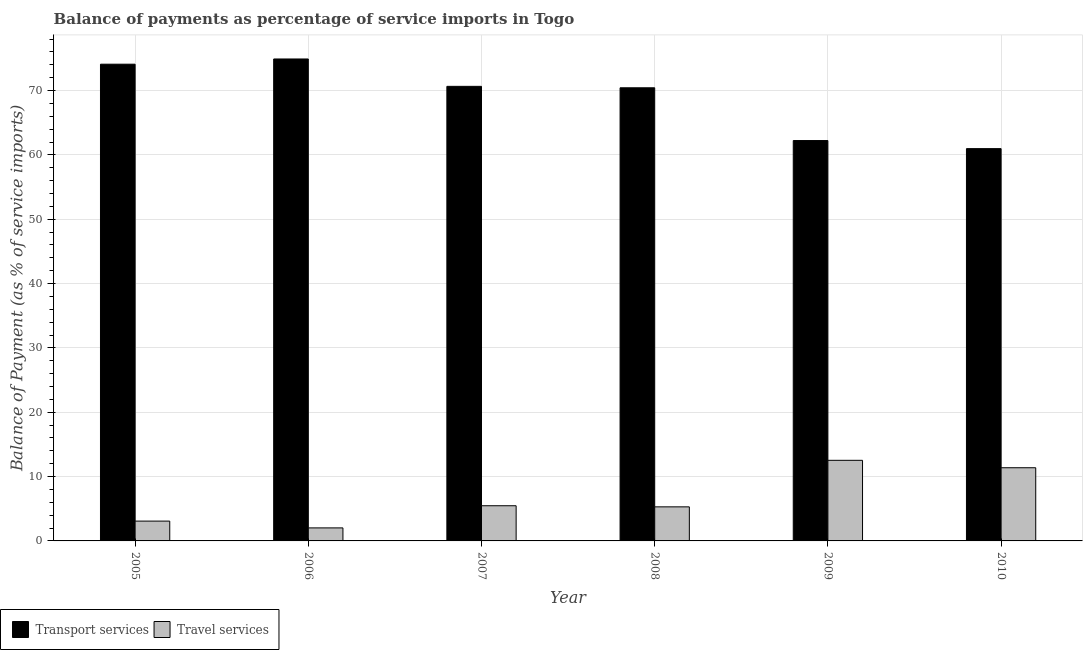Are the number of bars per tick equal to the number of legend labels?
Ensure brevity in your answer.  Yes. How many bars are there on the 5th tick from the left?
Ensure brevity in your answer.  2. What is the balance of payments of transport services in 2006?
Offer a very short reply. 74.91. Across all years, what is the maximum balance of payments of transport services?
Offer a terse response. 74.91. Across all years, what is the minimum balance of payments of travel services?
Give a very brief answer. 2.03. In which year was the balance of payments of transport services maximum?
Your response must be concise. 2006. What is the total balance of payments of travel services in the graph?
Provide a short and direct response. 39.77. What is the difference between the balance of payments of transport services in 2007 and that in 2008?
Keep it short and to the point. 0.22. What is the difference between the balance of payments of travel services in 2006 and the balance of payments of transport services in 2007?
Your response must be concise. -3.44. What is the average balance of payments of transport services per year?
Give a very brief answer. 68.88. What is the ratio of the balance of payments of transport services in 2007 to that in 2008?
Your answer should be compact. 1. What is the difference between the highest and the second highest balance of payments of travel services?
Offer a very short reply. 1.15. What is the difference between the highest and the lowest balance of payments of transport services?
Your response must be concise. 13.94. In how many years, is the balance of payments of travel services greater than the average balance of payments of travel services taken over all years?
Provide a succinct answer. 2. Is the sum of the balance of payments of travel services in 2008 and 2009 greater than the maximum balance of payments of transport services across all years?
Offer a terse response. Yes. What does the 1st bar from the left in 2008 represents?
Your response must be concise. Transport services. What does the 2nd bar from the right in 2008 represents?
Make the answer very short. Transport services. What is the difference between two consecutive major ticks on the Y-axis?
Your answer should be very brief. 10. Does the graph contain any zero values?
Ensure brevity in your answer.  No. Does the graph contain grids?
Your response must be concise. Yes. How many legend labels are there?
Offer a terse response. 2. What is the title of the graph?
Your answer should be compact. Balance of payments as percentage of service imports in Togo. What is the label or title of the Y-axis?
Provide a succinct answer. Balance of Payment (as % of service imports). What is the Balance of Payment (as % of service imports) in Transport services in 2005?
Make the answer very short. 74.1. What is the Balance of Payment (as % of service imports) of Travel services in 2005?
Your response must be concise. 3.08. What is the Balance of Payment (as % of service imports) of Transport services in 2006?
Keep it short and to the point. 74.91. What is the Balance of Payment (as % of service imports) in Travel services in 2006?
Provide a succinct answer. 2.03. What is the Balance of Payment (as % of service imports) in Transport services in 2007?
Provide a short and direct response. 70.65. What is the Balance of Payment (as % of service imports) of Travel services in 2007?
Your response must be concise. 5.47. What is the Balance of Payment (as % of service imports) in Transport services in 2008?
Provide a succinct answer. 70.43. What is the Balance of Payment (as % of service imports) in Travel services in 2008?
Your answer should be compact. 5.3. What is the Balance of Payment (as % of service imports) in Transport services in 2009?
Make the answer very short. 62.23. What is the Balance of Payment (as % of service imports) of Travel services in 2009?
Make the answer very short. 12.53. What is the Balance of Payment (as % of service imports) of Transport services in 2010?
Make the answer very short. 60.97. What is the Balance of Payment (as % of service imports) in Travel services in 2010?
Keep it short and to the point. 11.37. Across all years, what is the maximum Balance of Payment (as % of service imports) in Transport services?
Ensure brevity in your answer.  74.91. Across all years, what is the maximum Balance of Payment (as % of service imports) in Travel services?
Provide a succinct answer. 12.53. Across all years, what is the minimum Balance of Payment (as % of service imports) of Transport services?
Provide a succinct answer. 60.97. Across all years, what is the minimum Balance of Payment (as % of service imports) of Travel services?
Your response must be concise. 2.03. What is the total Balance of Payment (as % of service imports) in Transport services in the graph?
Make the answer very short. 413.3. What is the total Balance of Payment (as % of service imports) in Travel services in the graph?
Your answer should be compact. 39.77. What is the difference between the Balance of Payment (as % of service imports) of Transport services in 2005 and that in 2006?
Your response must be concise. -0.81. What is the difference between the Balance of Payment (as % of service imports) of Travel services in 2005 and that in 2006?
Provide a short and direct response. 1.06. What is the difference between the Balance of Payment (as % of service imports) in Transport services in 2005 and that in 2007?
Offer a terse response. 3.45. What is the difference between the Balance of Payment (as % of service imports) in Travel services in 2005 and that in 2007?
Offer a terse response. -2.39. What is the difference between the Balance of Payment (as % of service imports) in Transport services in 2005 and that in 2008?
Your response must be concise. 3.67. What is the difference between the Balance of Payment (as % of service imports) of Travel services in 2005 and that in 2008?
Provide a succinct answer. -2.22. What is the difference between the Balance of Payment (as % of service imports) of Transport services in 2005 and that in 2009?
Offer a terse response. 11.87. What is the difference between the Balance of Payment (as % of service imports) of Travel services in 2005 and that in 2009?
Make the answer very short. -9.45. What is the difference between the Balance of Payment (as % of service imports) in Transport services in 2005 and that in 2010?
Your response must be concise. 13.13. What is the difference between the Balance of Payment (as % of service imports) in Travel services in 2005 and that in 2010?
Give a very brief answer. -8.29. What is the difference between the Balance of Payment (as % of service imports) of Transport services in 2006 and that in 2007?
Ensure brevity in your answer.  4.26. What is the difference between the Balance of Payment (as % of service imports) of Travel services in 2006 and that in 2007?
Your answer should be compact. -3.44. What is the difference between the Balance of Payment (as % of service imports) in Transport services in 2006 and that in 2008?
Keep it short and to the point. 4.48. What is the difference between the Balance of Payment (as % of service imports) in Travel services in 2006 and that in 2008?
Offer a terse response. -3.27. What is the difference between the Balance of Payment (as % of service imports) of Transport services in 2006 and that in 2009?
Keep it short and to the point. 12.68. What is the difference between the Balance of Payment (as % of service imports) of Travel services in 2006 and that in 2009?
Your response must be concise. -10.5. What is the difference between the Balance of Payment (as % of service imports) in Transport services in 2006 and that in 2010?
Provide a succinct answer. 13.94. What is the difference between the Balance of Payment (as % of service imports) of Travel services in 2006 and that in 2010?
Give a very brief answer. -9.35. What is the difference between the Balance of Payment (as % of service imports) of Transport services in 2007 and that in 2008?
Offer a terse response. 0.22. What is the difference between the Balance of Payment (as % of service imports) of Travel services in 2007 and that in 2008?
Ensure brevity in your answer.  0.17. What is the difference between the Balance of Payment (as % of service imports) of Transport services in 2007 and that in 2009?
Offer a very short reply. 8.42. What is the difference between the Balance of Payment (as % of service imports) of Travel services in 2007 and that in 2009?
Make the answer very short. -7.06. What is the difference between the Balance of Payment (as % of service imports) in Transport services in 2007 and that in 2010?
Give a very brief answer. 9.68. What is the difference between the Balance of Payment (as % of service imports) in Travel services in 2007 and that in 2010?
Keep it short and to the point. -5.91. What is the difference between the Balance of Payment (as % of service imports) in Transport services in 2008 and that in 2009?
Provide a succinct answer. 8.2. What is the difference between the Balance of Payment (as % of service imports) of Travel services in 2008 and that in 2009?
Offer a terse response. -7.23. What is the difference between the Balance of Payment (as % of service imports) of Transport services in 2008 and that in 2010?
Give a very brief answer. 9.46. What is the difference between the Balance of Payment (as % of service imports) of Travel services in 2008 and that in 2010?
Provide a succinct answer. -6.08. What is the difference between the Balance of Payment (as % of service imports) in Transport services in 2009 and that in 2010?
Give a very brief answer. 1.26. What is the difference between the Balance of Payment (as % of service imports) in Travel services in 2009 and that in 2010?
Your answer should be very brief. 1.15. What is the difference between the Balance of Payment (as % of service imports) in Transport services in 2005 and the Balance of Payment (as % of service imports) in Travel services in 2006?
Keep it short and to the point. 72.07. What is the difference between the Balance of Payment (as % of service imports) in Transport services in 2005 and the Balance of Payment (as % of service imports) in Travel services in 2007?
Provide a succinct answer. 68.63. What is the difference between the Balance of Payment (as % of service imports) in Transport services in 2005 and the Balance of Payment (as % of service imports) in Travel services in 2008?
Your answer should be compact. 68.8. What is the difference between the Balance of Payment (as % of service imports) of Transport services in 2005 and the Balance of Payment (as % of service imports) of Travel services in 2009?
Your answer should be compact. 61.57. What is the difference between the Balance of Payment (as % of service imports) in Transport services in 2005 and the Balance of Payment (as % of service imports) in Travel services in 2010?
Offer a very short reply. 62.73. What is the difference between the Balance of Payment (as % of service imports) of Transport services in 2006 and the Balance of Payment (as % of service imports) of Travel services in 2007?
Provide a short and direct response. 69.44. What is the difference between the Balance of Payment (as % of service imports) in Transport services in 2006 and the Balance of Payment (as % of service imports) in Travel services in 2008?
Ensure brevity in your answer.  69.61. What is the difference between the Balance of Payment (as % of service imports) of Transport services in 2006 and the Balance of Payment (as % of service imports) of Travel services in 2009?
Give a very brief answer. 62.38. What is the difference between the Balance of Payment (as % of service imports) of Transport services in 2006 and the Balance of Payment (as % of service imports) of Travel services in 2010?
Your answer should be very brief. 63.54. What is the difference between the Balance of Payment (as % of service imports) of Transport services in 2007 and the Balance of Payment (as % of service imports) of Travel services in 2008?
Ensure brevity in your answer.  65.36. What is the difference between the Balance of Payment (as % of service imports) of Transport services in 2007 and the Balance of Payment (as % of service imports) of Travel services in 2009?
Offer a terse response. 58.13. What is the difference between the Balance of Payment (as % of service imports) of Transport services in 2007 and the Balance of Payment (as % of service imports) of Travel services in 2010?
Offer a very short reply. 59.28. What is the difference between the Balance of Payment (as % of service imports) in Transport services in 2008 and the Balance of Payment (as % of service imports) in Travel services in 2009?
Your answer should be very brief. 57.9. What is the difference between the Balance of Payment (as % of service imports) of Transport services in 2008 and the Balance of Payment (as % of service imports) of Travel services in 2010?
Your response must be concise. 59.06. What is the difference between the Balance of Payment (as % of service imports) of Transport services in 2009 and the Balance of Payment (as % of service imports) of Travel services in 2010?
Keep it short and to the point. 50.86. What is the average Balance of Payment (as % of service imports) in Transport services per year?
Provide a short and direct response. 68.88. What is the average Balance of Payment (as % of service imports) in Travel services per year?
Give a very brief answer. 6.63. In the year 2005, what is the difference between the Balance of Payment (as % of service imports) of Transport services and Balance of Payment (as % of service imports) of Travel services?
Provide a succinct answer. 71.02. In the year 2006, what is the difference between the Balance of Payment (as % of service imports) of Transport services and Balance of Payment (as % of service imports) of Travel services?
Keep it short and to the point. 72.88. In the year 2007, what is the difference between the Balance of Payment (as % of service imports) of Transport services and Balance of Payment (as % of service imports) of Travel services?
Your answer should be compact. 65.19. In the year 2008, what is the difference between the Balance of Payment (as % of service imports) in Transport services and Balance of Payment (as % of service imports) in Travel services?
Provide a succinct answer. 65.14. In the year 2009, what is the difference between the Balance of Payment (as % of service imports) of Transport services and Balance of Payment (as % of service imports) of Travel services?
Provide a short and direct response. 49.7. In the year 2010, what is the difference between the Balance of Payment (as % of service imports) in Transport services and Balance of Payment (as % of service imports) in Travel services?
Provide a succinct answer. 49.6. What is the ratio of the Balance of Payment (as % of service imports) in Travel services in 2005 to that in 2006?
Your response must be concise. 1.52. What is the ratio of the Balance of Payment (as % of service imports) of Transport services in 2005 to that in 2007?
Make the answer very short. 1.05. What is the ratio of the Balance of Payment (as % of service imports) of Travel services in 2005 to that in 2007?
Provide a succinct answer. 0.56. What is the ratio of the Balance of Payment (as % of service imports) in Transport services in 2005 to that in 2008?
Provide a succinct answer. 1.05. What is the ratio of the Balance of Payment (as % of service imports) of Travel services in 2005 to that in 2008?
Your response must be concise. 0.58. What is the ratio of the Balance of Payment (as % of service imports) in Transport services in 2005 to that in 2009?
Give a very brief answer. 1.19. What is the ratio of the Balance of Payment (as % of service imports) of Travel services in 2005 to that in 2009?
Your answer should be compact. 0.25. What is the ratio of the Balance of Payment (as % of service imports) in Transport services in 2005 to that in 2010?
Offer a very short reply. 1.22. What is the ratio of the Balance of Payment (as % of service imports) of Travel services in 2005 to that in 2010?
Offer a terse response. 0.27. What is the ratio of the Balance of Payment (as % of service imports) of Transport services in 2006 to that in 2007?
Your answer should be compact. 1.06. What is the ratio of the Balance of Payment (as % of service imports) in Travel services in 2006 to that in 2007?
Provide a succinct answer. 0.37. What is the ratio of the Balance of Payment (as % of service imports) in Transport services in 2006 to that in 2008?
Keep it short and to the point. 1.06. What is the ratio of the Balance of Payment (as % of service imports) of Travel services in 2006 to that in 2008?
Offer a very short reply. 0.38. What is the ratio of the Balance of Payment (as % of service imports) in Transport services in 2006 to that in 2009?
Your response must be concise. 1.2. What is the ratio of the Balance of Payment (as % of service imports) in Travel services in 2006 to that in 2009?
Offer a terse response. 0.16. What is the ratio of the Balance of Payment (as % of service imports) in Transport services in 2006 to that in 2010?
Offer a very short reply. 1.23. What is the ratio of the Balance of Payment (as % of service imports) of Travel services in 2006 to that in 2010?
Your answer should be compact. 0.18. What is the ratio of the Balance of Payment (as % of service imports) of Travel services in 2007 to that in 2008?
Offer a terse response. 1.03. What is the ratio of the Balance of Payment (as % of service imports) in Transport services in 2007 to that in 2009?
Provide a short and direct response. 1.14. What is the ratio of the Balance of Payment (as % of service imports) of Travel services in 2007 to that in 2009?
Make the answer very short. 0.44. What is the ratio of the Balance of Payment (as % of service imports) in Transport services in 2007 to that in 2010?
Make the answer very short. 1.16. What is the ratio of the Balance of Payment (as % of service imports) of Travel services in 2007 to that in 2010?
Make the answer very short. 0.48. What is the ratio of the Balance of Payment (as % of service imports) of Transport services in 2008 to that in 2009?
Offer a very short reply. 1.13. What is the ratio of the Balance of Payment (as % of service imports) of Travel services in 2008 to that in 2009?
Your response must be concise. 0.42. What is the ratio of the Balance of Payment (as % of service imports) of Transport services in 2008 to that in 2010?
Offer a very short reply. 1.16. What is the ratio of the Balance of Payment (as % of service imports) in Travel services in 2008 to that in 2010?
Make the answer very short. 0.47. What is the ratio of the Balance of Payment (as % of service imports) of Transport services in 2009 to that in 2010?
Your response must be concise. 1.02. What is the ratio of the Balance of Payment (as % of service imports) in Travel services in 2009 to that in 2010?
Your response must be concise. 1.1. What is the difference between the highest and the second highest Balance of Payment (as % of service imports) in Transport services?
Your response must be concise. 0.81. What is the difference between the highest and the second highest Balance of Payment (as % of service imports) of Travel services?
Your answer should be very brief. 1.15. What is the difference between the highest and the lowest Balance of Payment (as % of service imports) of Transport services?
Your answer should be compact. 13.94. What is the difference between the highest and the lowest Balance of Payment (as % of service imports) of Travel services?
Provide a short and direct response. 10.5. 